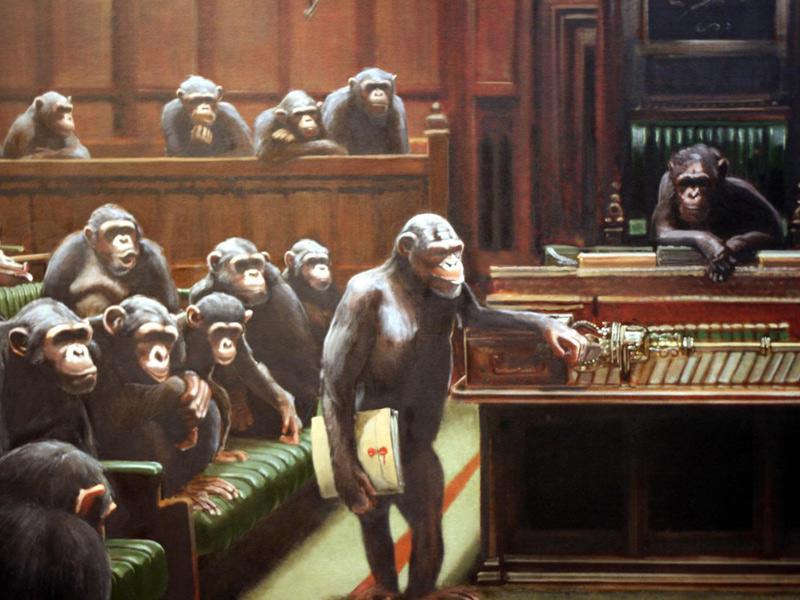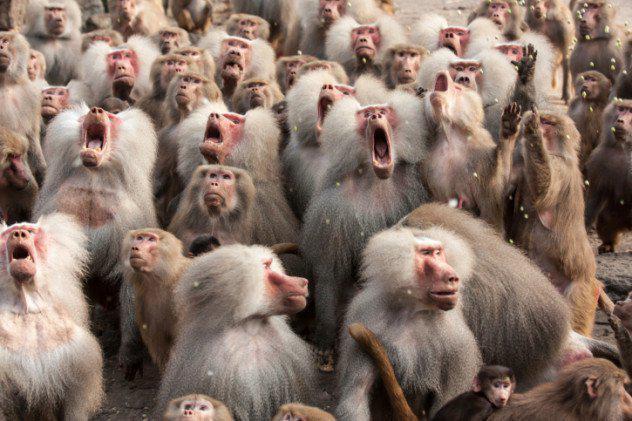The first image is the image on the left, the second image is the image on the right. Considering the images on both sides, is "there are man made objects in the image on the left." valid? Answer yes or no. Yes. 